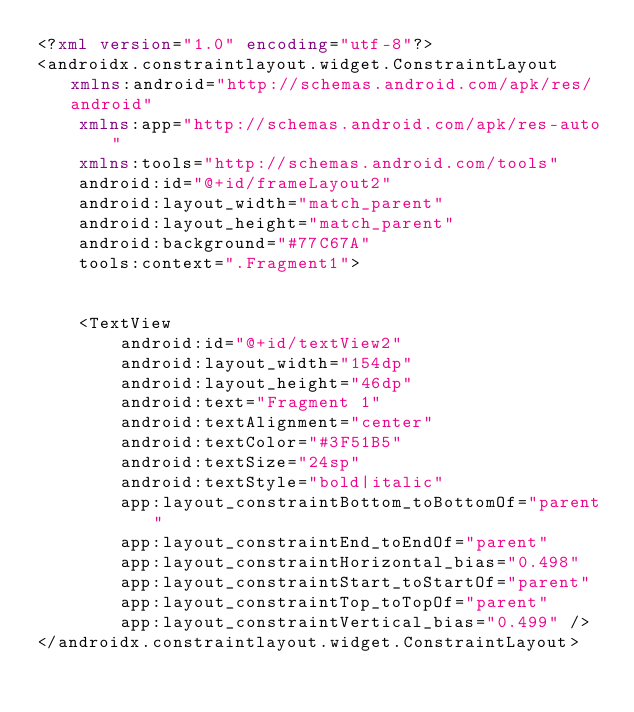Convert code to text. <code><loc_0><loc_0><loc_500><loc_500><_XML_><?xml version="1.0" encoding="utf-8"?>
<androidx.constraintlayout.widget.ConstraintLayout xmlns:android="http://schemas.android.com/apk/res/android"
    xmlns:app="http://schemas.android.com/apk/res-auto"
    xmlns:tools="http://schemas.android.com/tools"
    android:id="@+id/frameLayout2"
    android:layout_width="match_parent"
    android:layout_height="match_parent"
    android:background="#77C67A"
    tools:context=".Fragment1">


    <TextView
        android:id="@+id/textView2"
        android:layout_width="154dp"
        android:layout_height="46dp"
        android:text="Fragment 1"
        android:textAlignment="center"
        android:textColor="#3F51B5"
        android:textSize="24sp"
        android:textStyle="bold|italic"
        app:layout_constraintBottom_toBottomOf="parent"
        app:layout_constraintEnd_toEndOf="parent"
        app:layout_constraintHorizontal_bias="0.498"
        app:layout_constraintStart_toStartOf="parent"
        app:layout_constraintTop_toTopOf="parent"
        app:layout_constraintVertical_bias="0.499" />
</androidx.constraintlayout.widget.ConstraintLayout></code> 